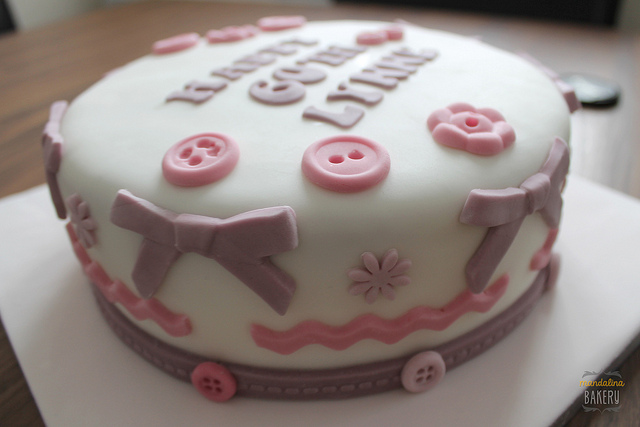Read and extract the text from this image. HAPPY 60th mandalina BAKERY 